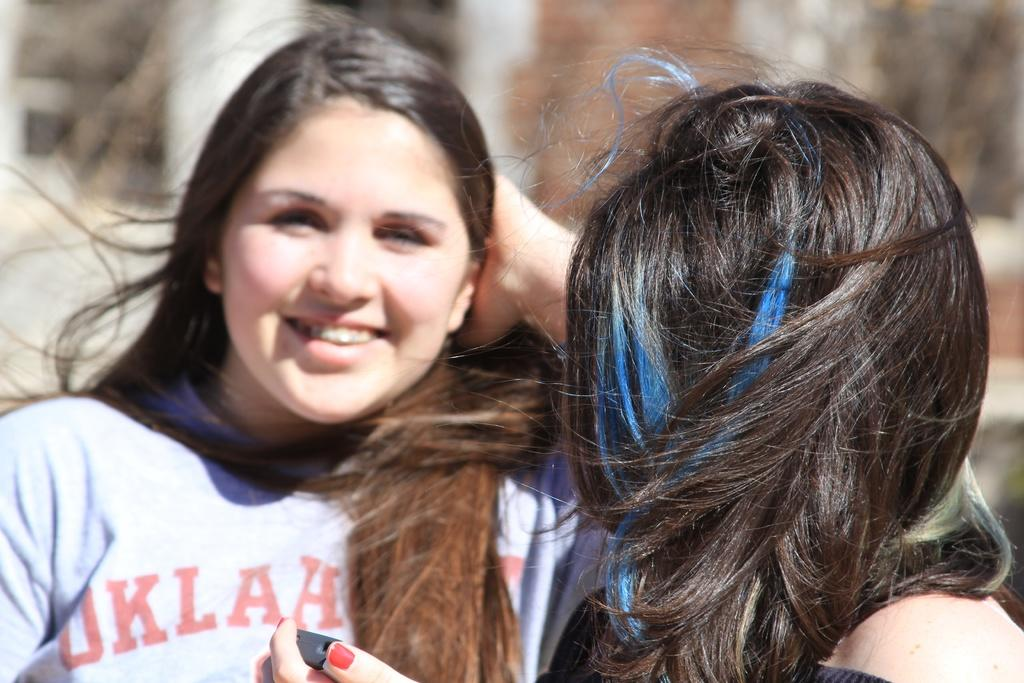What is the woman in the white T-shirt doing in the image? The woman in the white T-shirt is smiling in the image. What is the woman in the black dress holding in the image? The woman in the black dress is holding a cell phone in the image. Can you describe the clothing of the two women in the image? One woman is wearing a white T-shirt, and the other woman is wearing a black dress. What is the condition of the background in the image? The background of the image is blurred. What decision does the woman in the black dress regret in the image? There is no indication in the image that the woman in the black dress regrets any decision. 